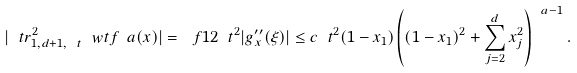Convert formula to latex. <formula><loc_0><loc_0><loc_500><loc_500>| \ t r ^ { 2 } _ { 1 , d + 1 , \ t } \ w t f _ { \ } a ( x ) | = \ f 1 2 \ t ^ { 2 } | g _ { x } ^ { \prime \prime } ( \xi ) | \leq c \ t ^ { 2 } ( 1 - x _ { 1 } ) \left ( ( 1 - x _ { 1 } ) ^ { 2 } + \sum _ { j = 2 } ^ { d } x _ { j } ^ { 2 } \right ) ^ { \ a - 1 } .</formula> 